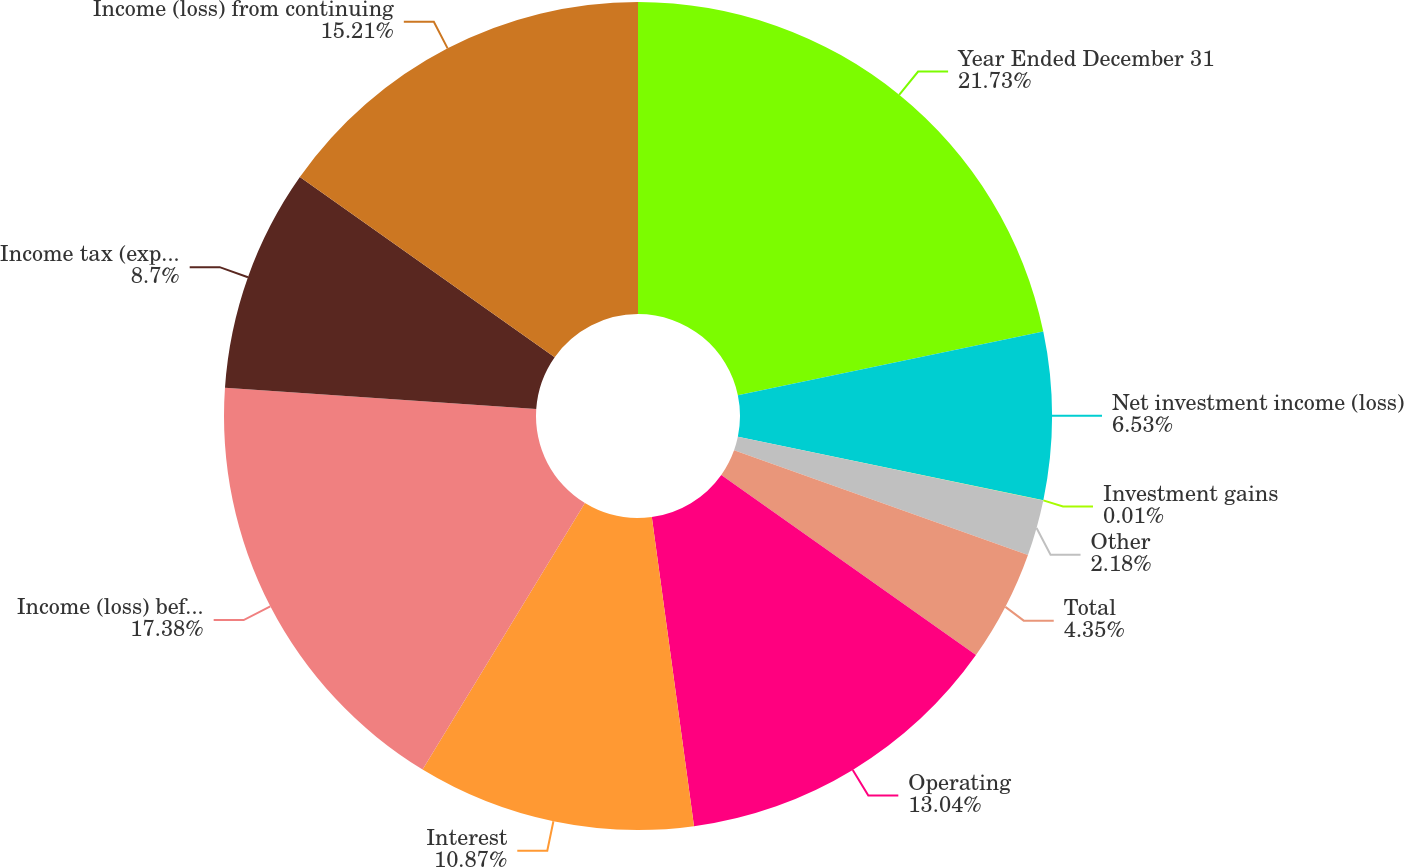Convert chart to OTSL. <chart><loc_0><loc_0><loc_500><loc_500><pie_chart><fcel>Year Ended December 31<fcel>Net investment income (loss)<fcel>Investment gains<fcel>Other<fcel>Total<fcel>Operating<fcel>Interest<fcel>Income (loss) before income<fcel>Income tax (expense) benefit<fcel>Income (loss) from continuing<nl><fcel>21.73%<fcel>6.53%<fcel>0.01%<fcel>2.18%<fcel>4.35%<fcel>13.04%<fcel>10.87%<fcel>17.38%<fcel>8.7%<fcel>15.21%<nl></chart> 